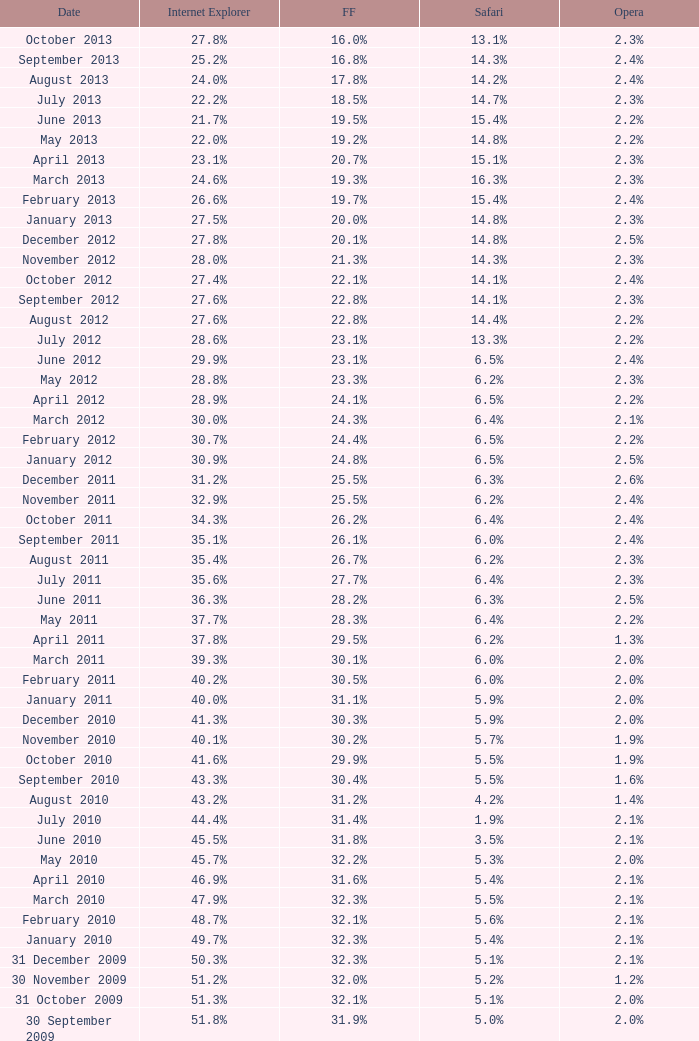What is the firefox value with a 1.8% opera on 30 July 2007? 25.1%. 